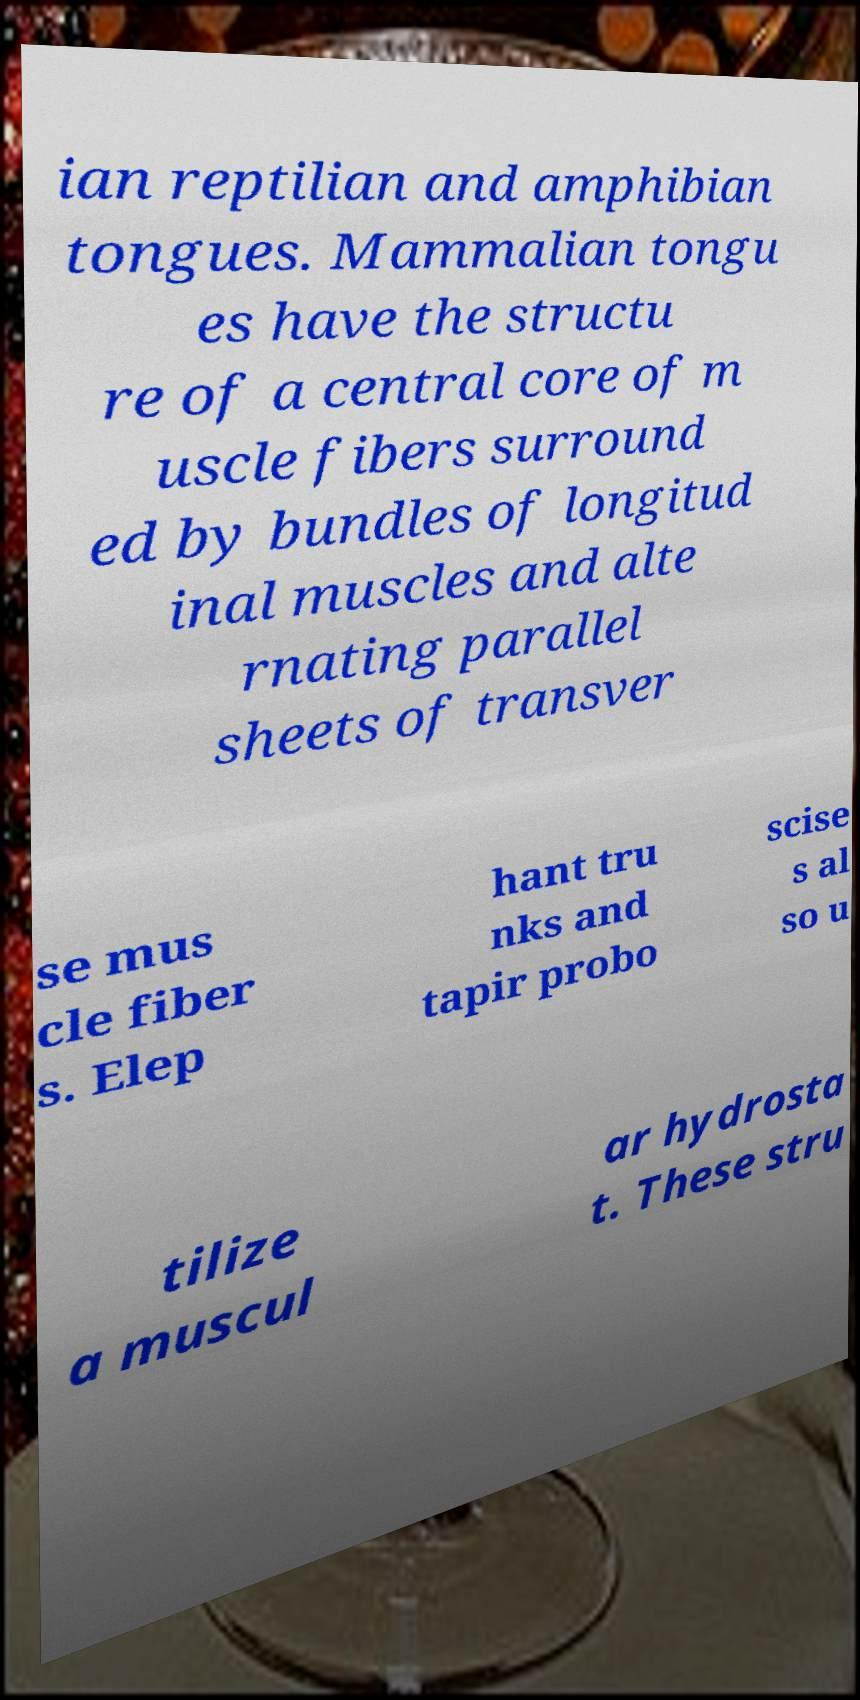Could you extract and type out the text from this image? ian reptilian and amphibian tongues. Mammalian tongu es have the structu re of a central core of m uscle fibers surround ed by bundles of longitud inal muscles and alte rnating parallel sheets of transver se mus cle fiber s. Elep hant tru nks and tapir probo scise s al so u tilize a muscul ar hydrosta t. These stru 